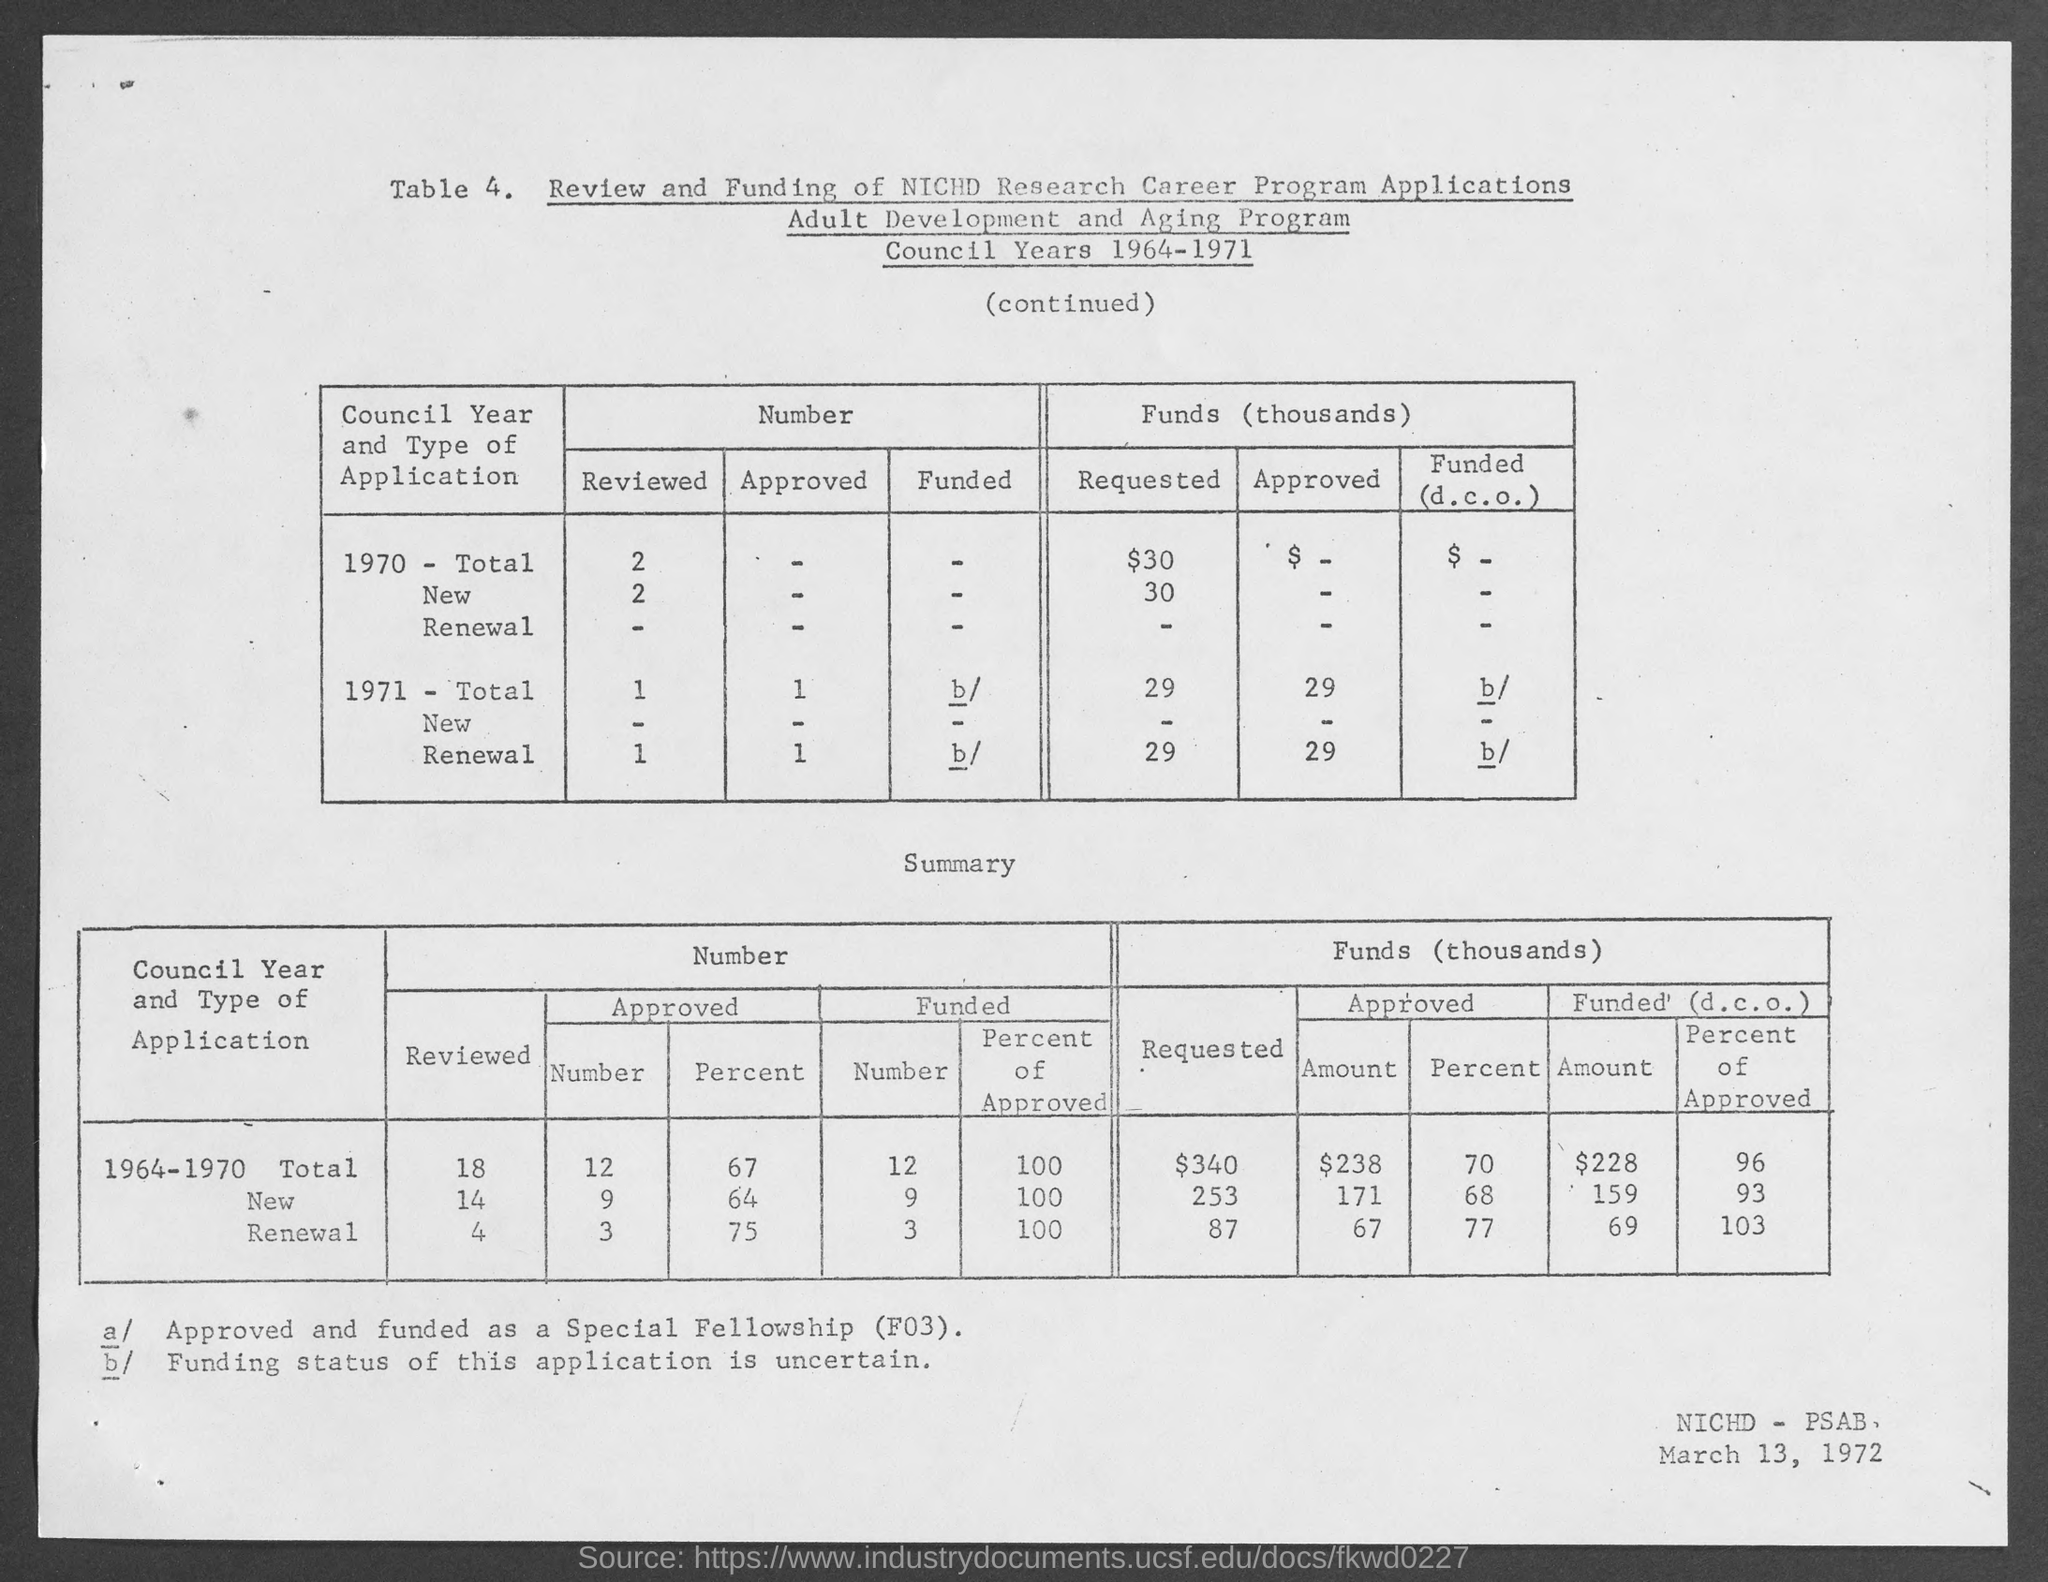What is the date at bottom- right corner of the page ?
Offer a very short reply. March 13, 1972. 